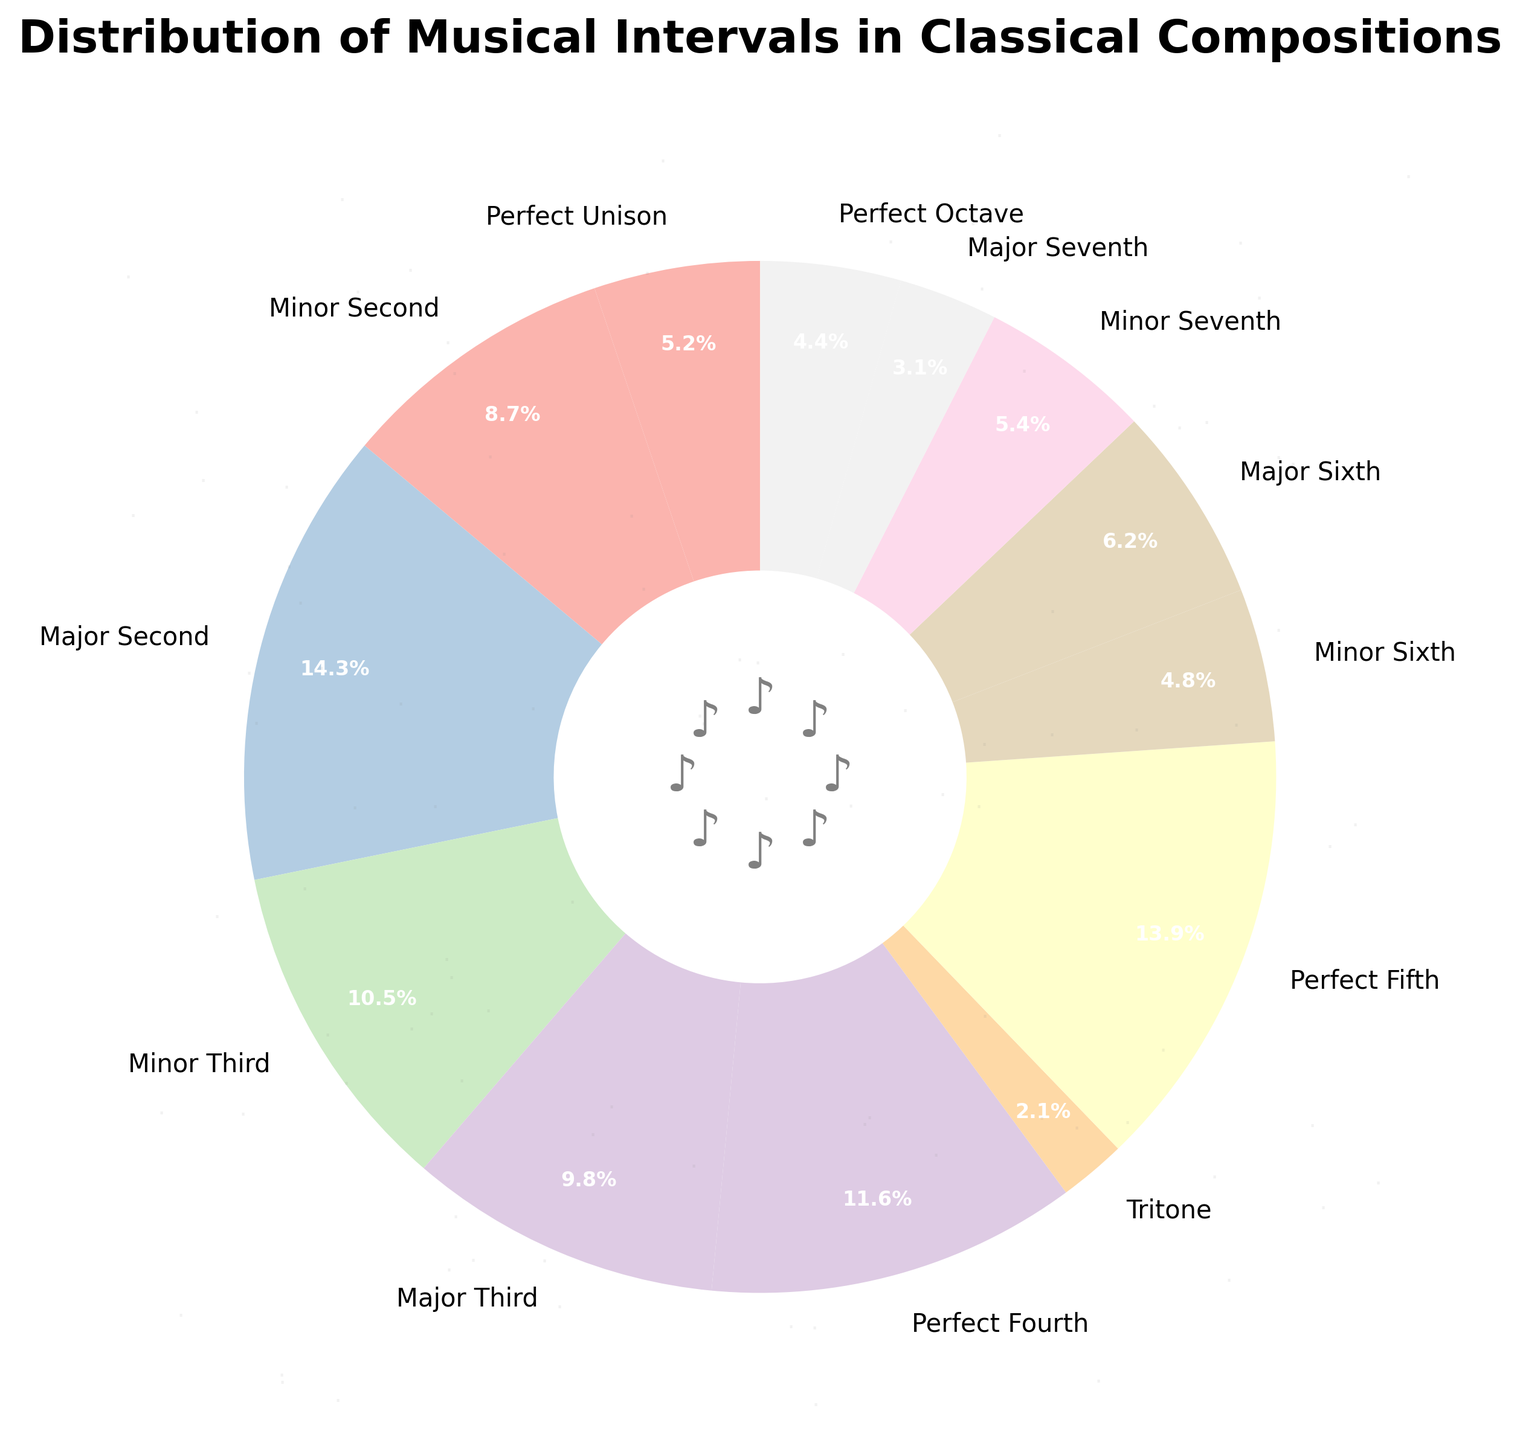What is the most common musical interval used in classical compositions according to the plot? The largest wedge represents the Major Second, which has the highest percentage.
Answer: Major Second Compare the percentages of Perfect Fifth and Perfect Fourth. Which one is higher, and by how much? The Perfect Fifth is at 13.9%, and the Perfect Fourth is at 11.6%. The Perfect Fifth is higher. The difference is calculated as 13.9% - 11.6% = 2.3%.
Answer: Perfect Fifth by 2.3% Which musical interval has the lowest occurrence, and what is its percentage? The smallest wedge represents the Tritone, which has the lowest percentage.
Answer: Tritone, 2.1% What is the total percentage of consonant intervals (Perfect Unison, Perfect Fourth, Perfect Fifth, Perfect Octave) shown in the plot? Adding the percentages: Perfect Unison (5.2%), Perfect Fourth (11.6%), Perfect Fifth (13.9%), Perfect Octave (4.4%): 5.2 + 11.6 + 13.9 + 4.4 = 35.1%
Answer: 35.1% Is the percentage of Major Third intervals higher than Minor Third intervals? The percentage of Major Third is 9.8%, while the percentage of Minor Third is 10.5%. Major Third is not higher than Minor Third.
Answer: No Which interval is closest in percentage to the Minor Seventh interval? The Minor Seventh is at 5.4%. The closest interval is Perfect Unison at 5.2%.
Answer: Perfect Unison What is the combined percentage of the Minor Sixth and Major Sixth intervals? Adding the percentages: Minor Sixth (4.8%) and Major Sixth (6.2%): 4.8 + 6.2 = 11.0%
Answer: 11.0% Are there any intervals with a percentage between 3% and 5%? If so, which ones? Checking intervals: Perfect Unison (5.2%), Minor Sixth (4.8%), Perfect Octave (4.4%), Minor Seventh (5.4%), Major Seventh (3.1%). Only Perfect Octave and Major Seventh fall in that range.
Answer: Perfect Octave, Major Seventh Which has a higher percentage: Tritone or Perfect Octave? And what is the difference in percentage between them? The Tritone is at 2.1%, and the Perfect Octave is at 4.4%. The Perfect Octave is higher. The difference is 4.4% - 2.1% = 2.3%.
Answer: Perfect Octave by 2.3% 